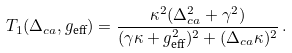Convert formula to latex. <formula><loc_0><loc_0><loc_500><loc_500>T _ { 1 } ( \Delta _ { c a } , g _ { \text {eff} } ) = \frac { \kappa ^ { 2 } ( \Delta _ { c a } ^ { 2 } + \gamma ^ { 2 } ) } { ( \gamma \kappa + g _ { \text {eff} } ^ { 2 } ) ^ { 2 } + ( \Delta _ { c a } \kappa ) ^ { 2 } } \, .</formula> 